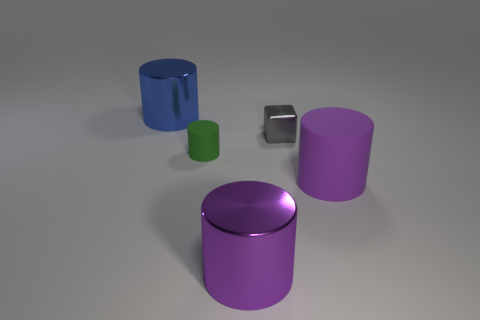Subtract all brown blocks. Subtract all green spheres. How many blocks are left? 1 Add 2 gray metal objects. How many objects exist? 7 Subtract all cylinders. How many objects are left? 1 Add 1 shiny cubes. How many shiny cubes exist? 2 Subtract 0 yellow blocks. How many objects are left? 5 Subtract all large cyan shiny cylinders. Subtract all purple shiny things. How many objects are left? 4 Add 1 gray objects. How many gray objects are left? 2 